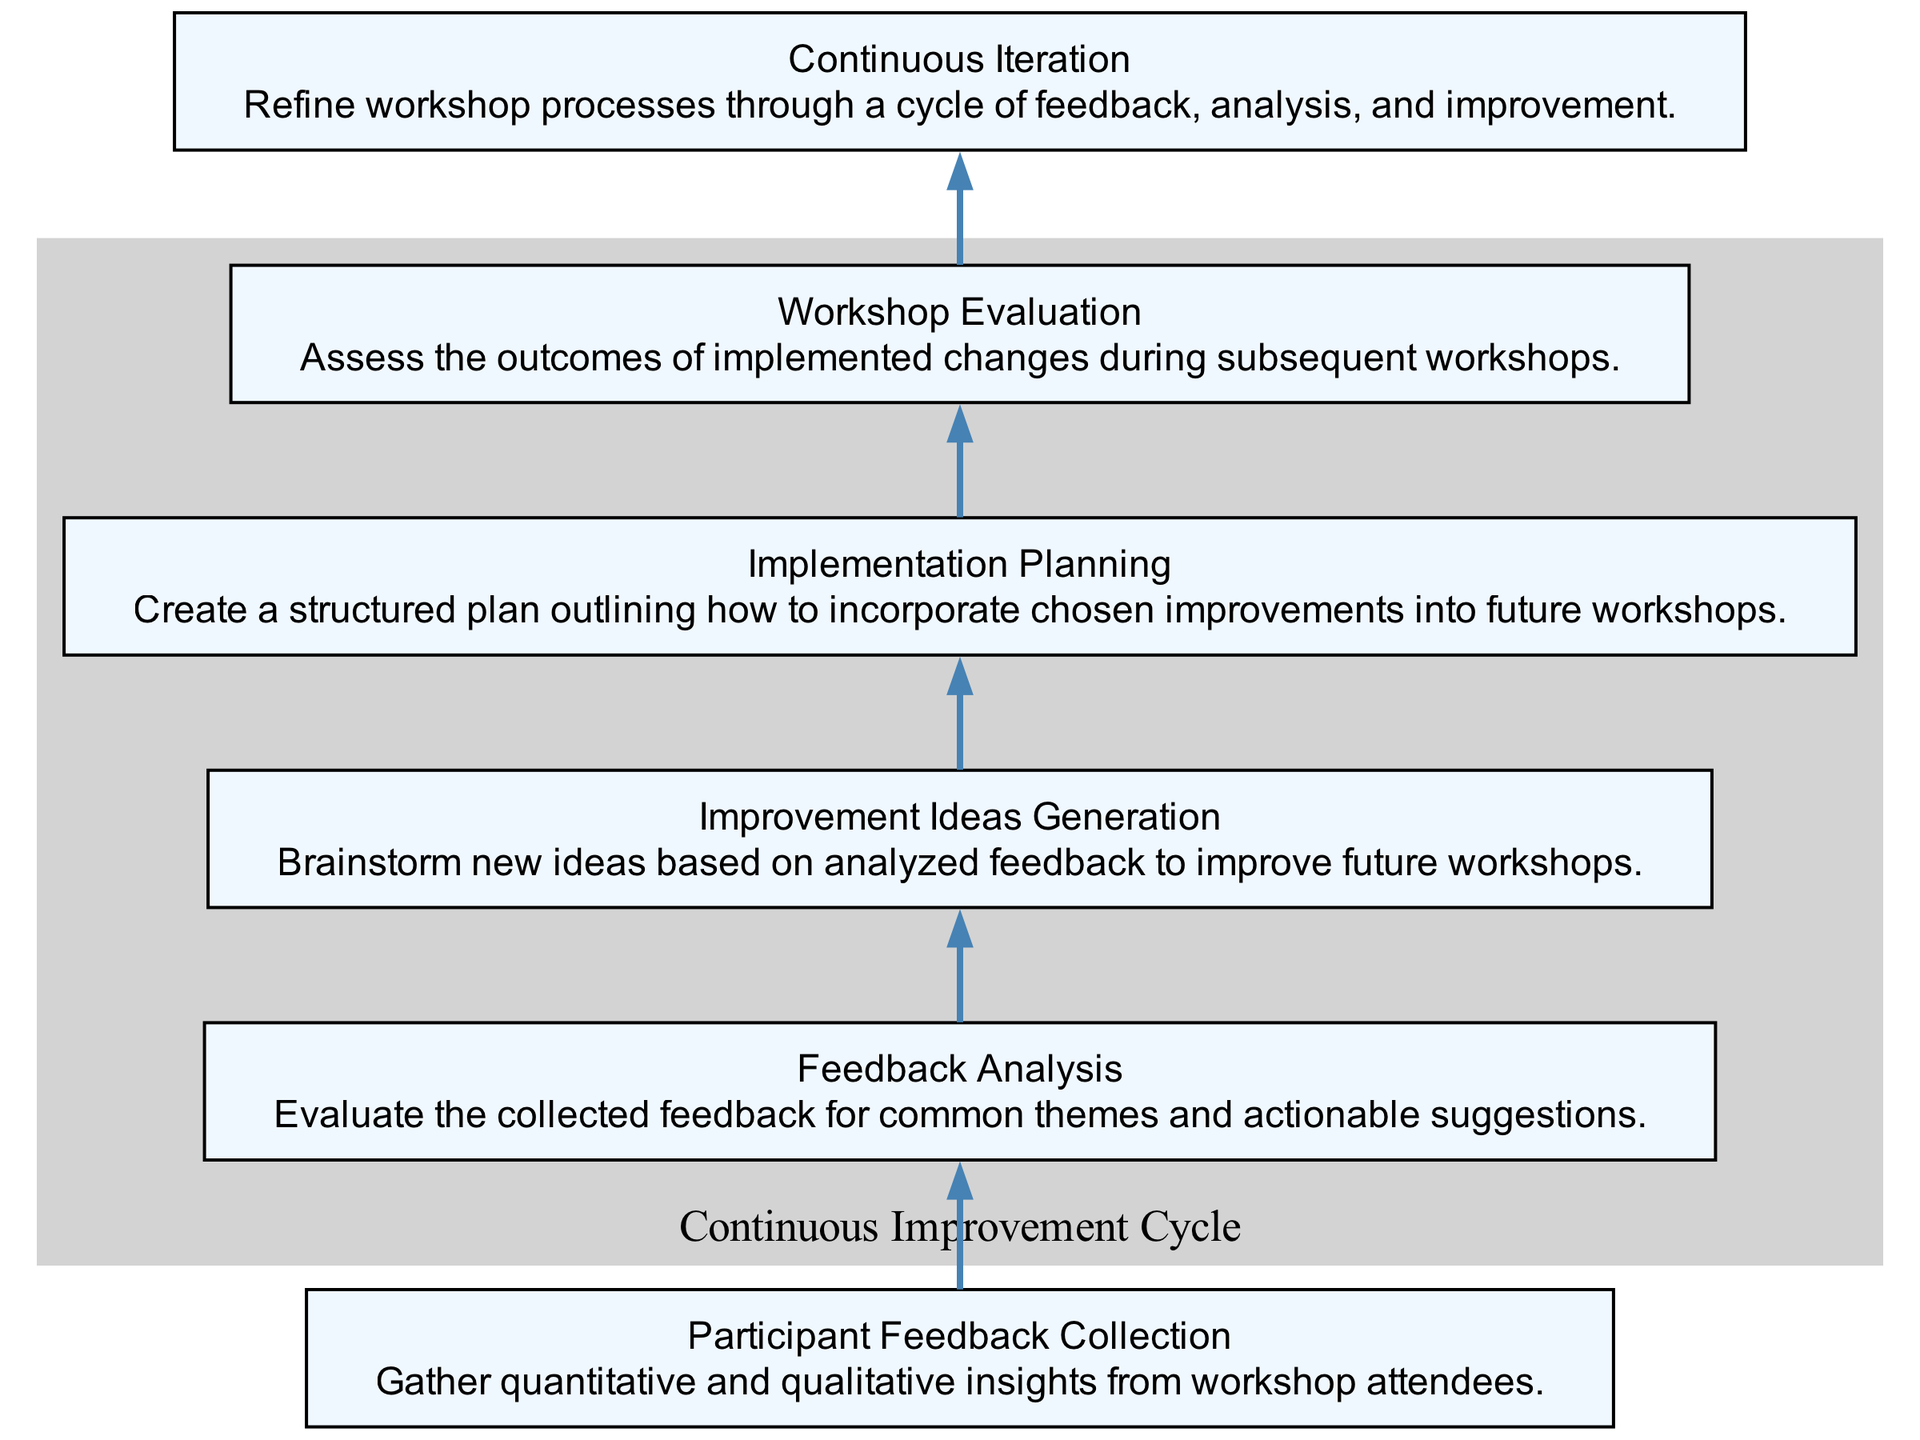What is the first step in the workshop feedback process? The diagram shows that the first step is "Participant Feedback Collection," which is the initial action to gather insights from workshop attendees.
Answer: Participant Feedback Collection How many nodes are in the diagram? By counting each distinct labeled rectangle in the diagram, there are a total of six nodes representing different steps in the workshop feedback process.
Answer: 6 What comes after feedback analysis in the cycle? According to the flow of the diagram, after "Feedback Analysis," the next step is "Improvement Ideas Generation," indicating the progression from analyzing feedback to generating actionable ideas.
Answer: Improvement Ideas Generation Which node is connected to "Continuous Iteration"? Looking at the flow, "Continuous Iteration" is connected to "Workshop Evaluation," as it follows the evaluation of implemented changes in the workshops.
Answer: Workshop Evaluation What is the relationship between "Improvement Ideas Generation" and "Implementation Planning"? The diagram indicates that there is a directed flow from "Improvement Ideas Generation" to "Implementation Planning," signifying that generated ideas lead to creating an actionable plan.
Answer: Directed flow What is the visual cue used to group certain nodes in the diagram? The nodes are grouped under a subgraph labeled "Continuous Improvement Cycle," which is highlighted with a light grey background to show that these nodes are part of the same iterative process.
Answer: Light grey background What process type is described in the diagram? The diagram outlines a "Bottom Up Flow Chart," as it starts with feedback collection and iterates through analysis and improvements, showcasing the continuous refining process.
Answer: Bottom Up Flow Chart What does "Workshop Evaluation" lead to in this flow? Following the flow from "Workshop Evaluation," it leads to "Continuous Iteration," which emphasizes the ongoing process of refining and improving workshops based on evaluations.
Answer: Continuous Iteration How many edges are there in the diagram? Each connection between two nodes represents an edge. Counting the directed connections in the diagram, there are five edges depicting the flow from one step to another.
Answer: 5 